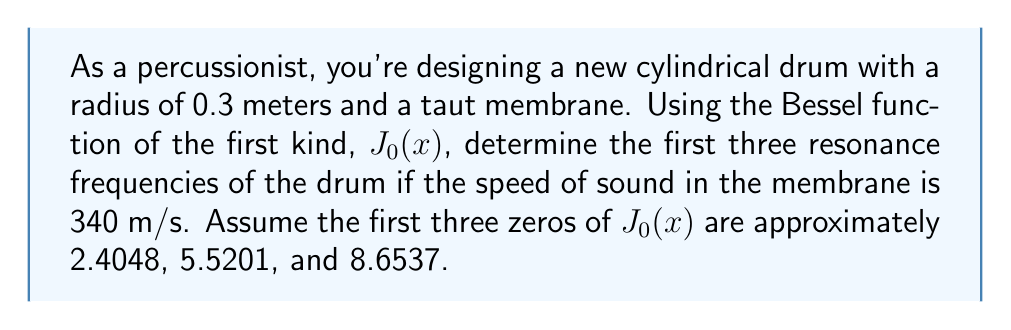Help me with this question. To solve this problem, we'll follow these steps:

1) The resonance frequencies of a circular membrane are given by the formula:

   $$f_{mn} = \frac{c \alpha_{mn}}{2\pi a}$$

   where:
   - $f_{mn}$ is the resonance frequency
   - $c$ is the speed of sound in the membrane
   - $a$ is the radius of the drum
   - $\alpha_{mn}$ are the zeros of the Bessel function $J_m(x)$

2) For the fundamental mode and its overtones, we're concerned with $J_0(x)$, so $m=0$.

3) We're given:
   - $c = 340$ m/s
   - $a = 0.3$ m
   - The first three zeros of $J_0(x)$: $\alpha_{01} \approx 2.4048$, $\alpha_{02} \approx 5.5201$, $\alpha_{03} \approx 8.6537$

4) Let's calculate the first three resonance frequencies:

   For $n=1$: 
   $$f_{01} = \frac{340 \cdot 2.4048}{2\pi \cdot 0.3} \approx 432.35 \text{ Hz}$$

   For $n=2$:
   $$f_{02} = \frac{340 \cdot 5.5201}{2\pi \cdot 0.3} \approx 992.62 \text{ Hz}$$

   For $n=3$:
   $$f_{03} = \frac{340 \cdot 8.6537}{2\pi \cdot 0.3} \approx 1555.92 \text{ Hz}$$

5) Rounding to the nearest whole number:
   $f_{01} \approx 432 \text{ Hz}$
   $f_{02} \approx 993 \text{ Hz}$
   $f_{03} \approx 1556 \text{ Hz}$
Answer: 432 Hz, 993 Hz, 1556 Hz 